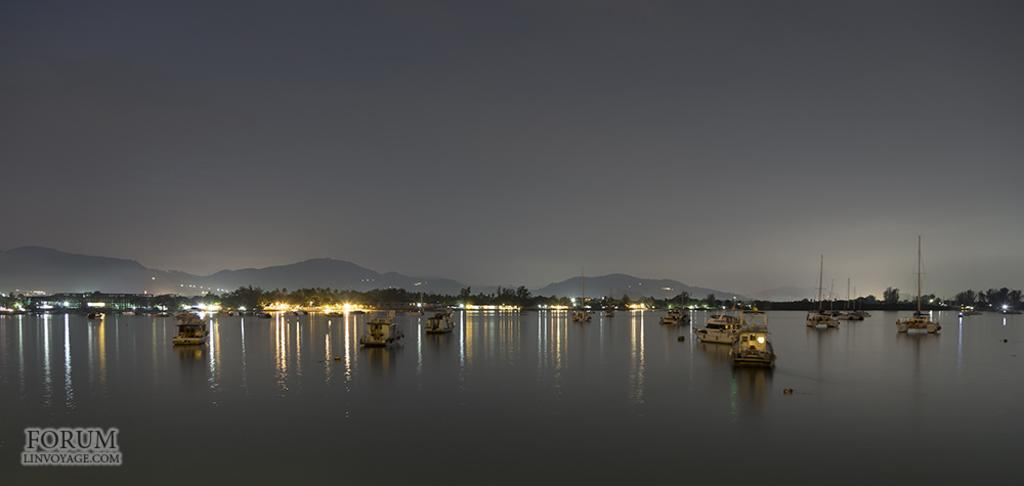What is floating on the water in the image? There are boards on the water in the image. What type of natural environment is visible in the background of the image? There are trees, mountains, and the sky visible in the background of the image. Can you describe the watermark in the image? Unfortunately, the details of the watermark cannot be determined from the image. How does the water blow the boards in the image? The water does not blow the boards in the image; the boards are floating on the water. What type of learning can be observed in the image? There is no learning activity depicted in the image; it features boards floating on water and a natural background. 